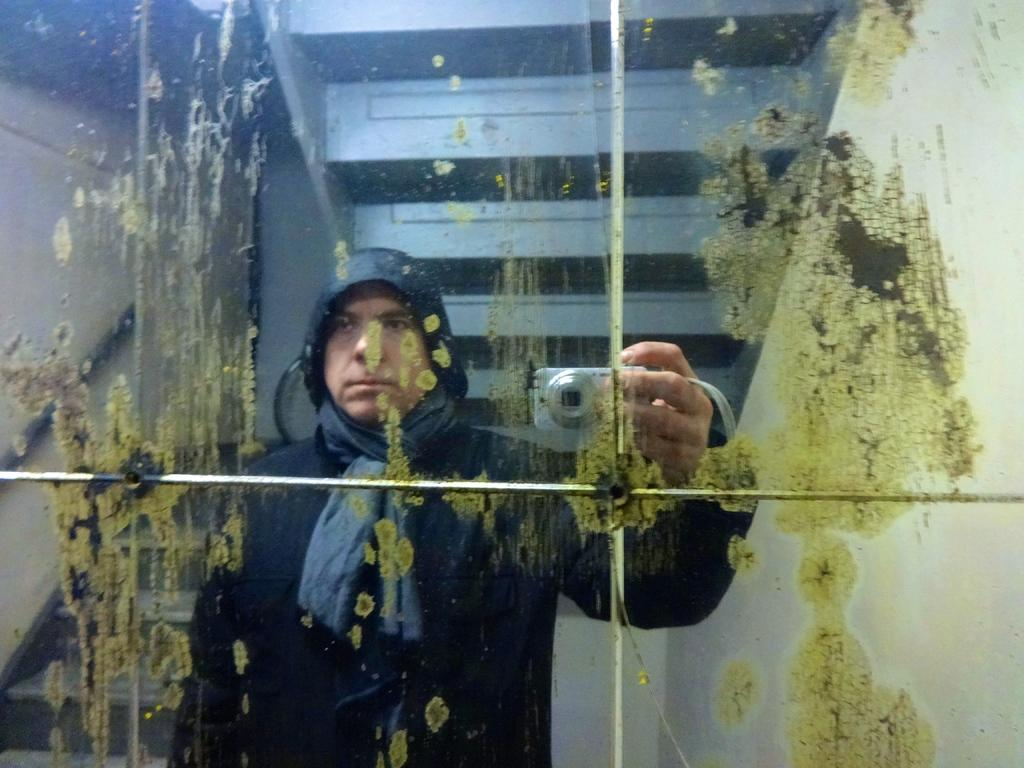What object is present in the image that allows for reflection? There is a mirror in the image. What can be seen in the mirror? A person wearing a black color dress and the person holding the camera are visible in the mirror. What architectural feature is visible in the mirror? There are stairs visible in the mirror. What type of calculator is being used by the person in the mirror? There is no calculator present in the image; it only features a mirror, a person wearing a black color dress, and the person holding the camera. 